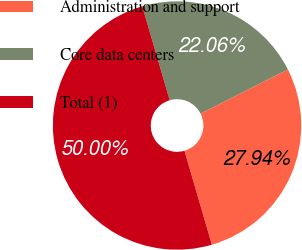<chart> <loc_0><loc_0><loc_500><loc_500><pie_chart><fcel>Administration and support<fcel>Core data centers<fcel>Total (1)<nl><fcel>27.94%<fcel>22.06%<fcel>50.0%<nl></chart> 